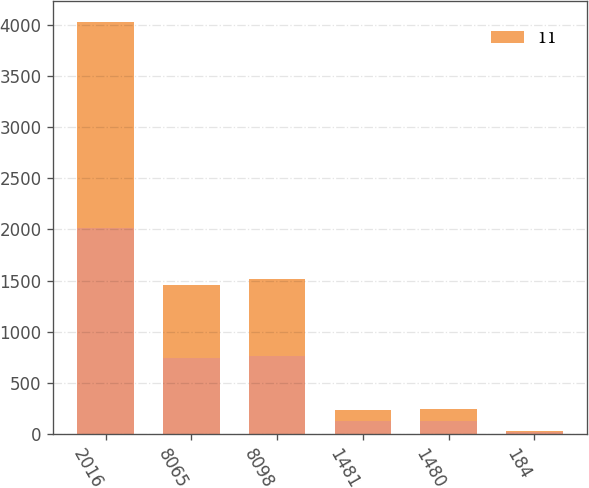Convert chart to OTSL. <chart><loc_0><loc_0><loc_500><loc_500><stacked_bar_chart><ecel><fcel>2016<fcel>8065<fcel>8098<fcel>1481<fcel>1480<fcel>184<nl><fcel>nan<fcel>2015<fcel>747.1<fcel>763.4<fcel>127.5<fcel>129.3<fcel>17.1<nl><fcel>11<fcel>2014<fcel>705.2<fcel>751.8<fcel>109.9<fcel>116.3<fcel>15.6<nl></chart> 